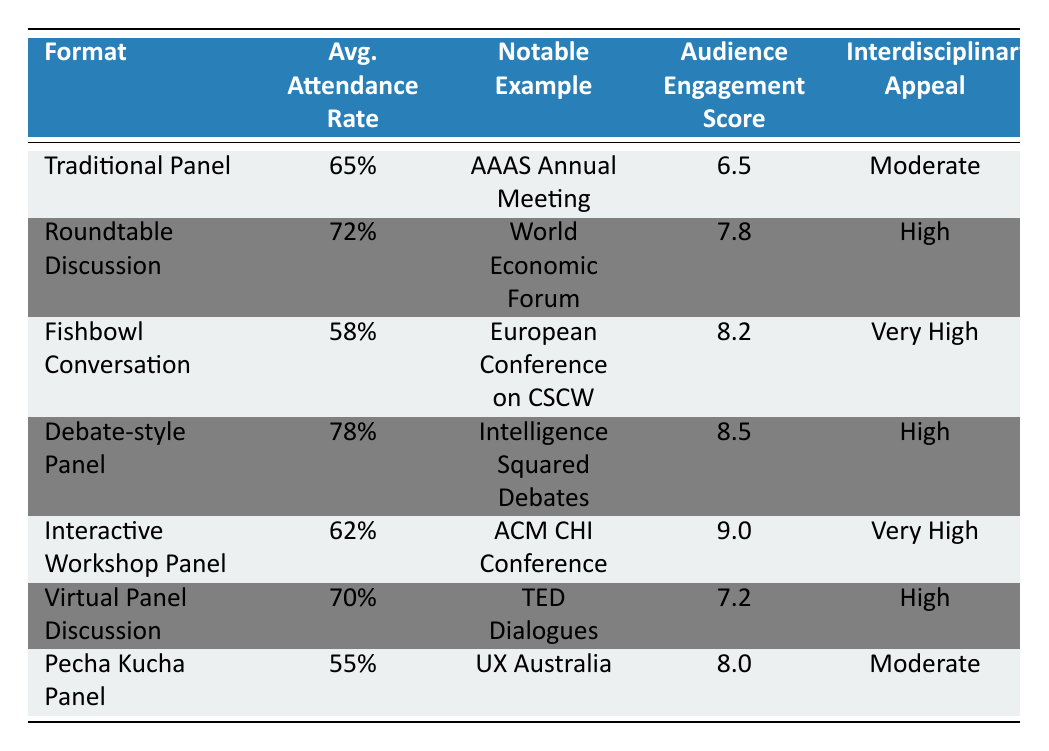What is the average attendance rate for Debate-style Panel? The table shows the average attendance rate for the Debate-style Panel, which is listed directly under the "Average Attendance Rate" column. It is 78%.
Answer: 78% Which panel discussion format has the highest audience engagement score? By comparing the "Audience Engagement Score" column, we see that the Debate-style Panel has the highest score listed at 8.5.
Answer: Debate-style Panel Is the interdisciplinary appeal of the Fishbowl Conversation very high? The table lists "Interdisciplinary Appeal" of Fishbowl Conversation as "Very High", so the answer is yes.
Answer: Yes What is the difference in average attendance rates between Roundtable Discussion and Pecha Kucha Panel? The attendance rate for Roundtable Discussion is 72%, and for Pecha Kucha Panel, it is 55%. To find the difference: 72% - 55% = 17%.
Answer: 17% What is the average audience engagement score for all panel formats listed? To find the average, sum the audience engagement scores (6.5 + 7.8 + 8.2 + 8.5 + 9.0 + 7.2 + 8.0 = 55.2) and divide by the number of formats (7): 55.2 / 7 = 7.8857 (approximately 7.9).
Answer: 7.9 What is the notable example of the Interactive Workshop Panel? The "Notable Example" column for the Interactive Workshop Panel shows "ACM CHI Conference on Human Factors in Computing Systems" as its example.
Answer: ACM CHI Conference on Human Factors in Computing Systems Does the Virtual Panel Discussion have a higher attendance rate than the Traditional Panel? The attendance rate for Virtual Panel Discussion is 70%, while for Traditional Panel, it is 65%. Since 70% is greater than 65%, the answer is yes.
Answer: Yes Which format has a higher average attendance rate: Fishbowl Conversation or Interactive Workshop Panel? The average attendance rate for Fishbowl Conversation is 58% and for Interactive Workshop Panel it is 62%. Comparing these values, 62% is higher than 58%.
Answer: Interactive Workshop Panel How many formats have an interdisciplinary appeal classified as "Very High"? By examining the "Interdisciplinary Appeal" column, we identify that Fishbowl Conversation and Interactive Workshop Panel are both classified as "Very High". Therefore, there are two formats.
Answer: 2 